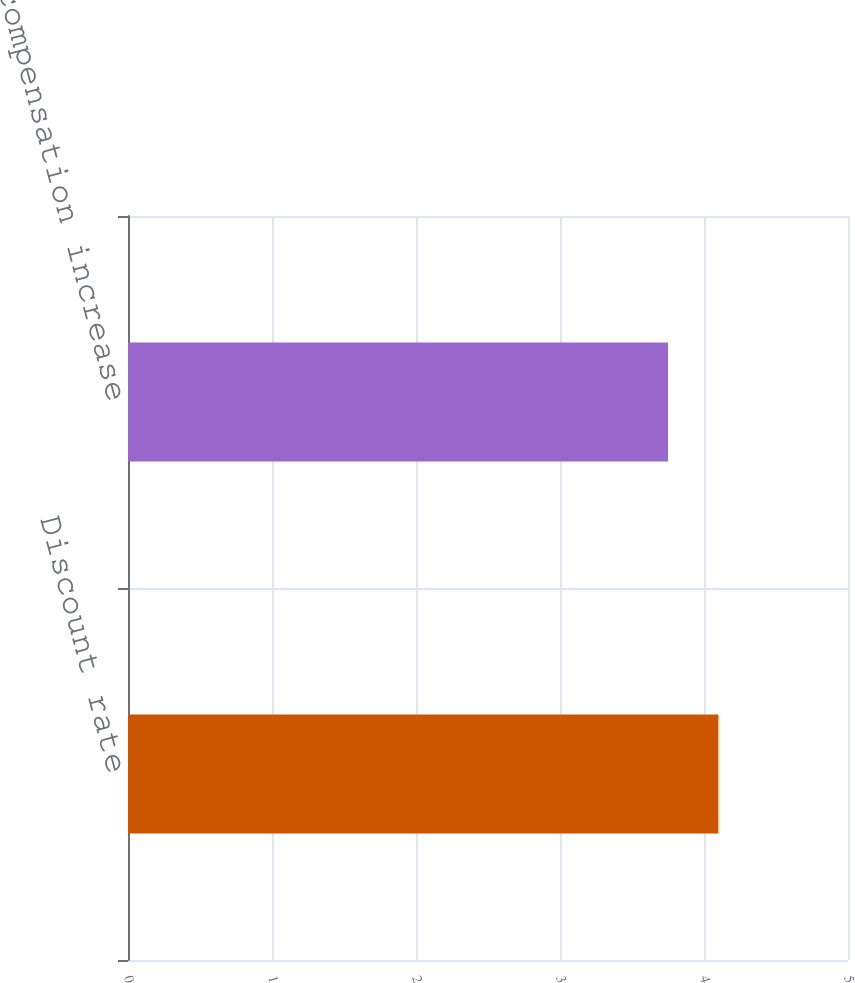<chart> <loc_0><loc_0><loc_500><loc_500><bar_chart><fcel>Discount rate<fcel>Rate of compensation increase<nl><fcel>4.1<fcel>3.75<nl></chart> 